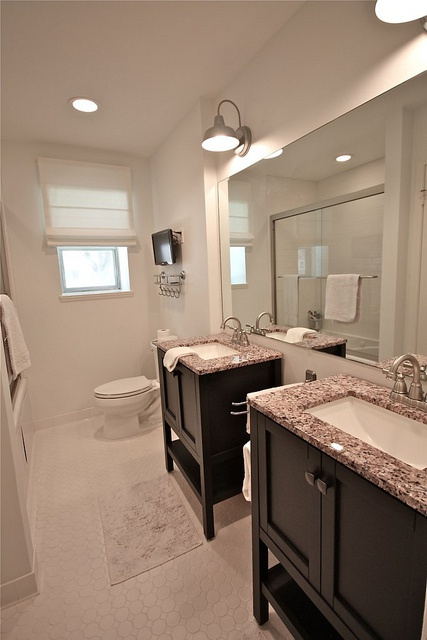Describe the objects in this image and their specific colors. I can see sink in darkgray, tan, and gray tones, toilet in darkgray, tan, and gray tones, and sink in darkgray, tan, and gray tones in this image. 